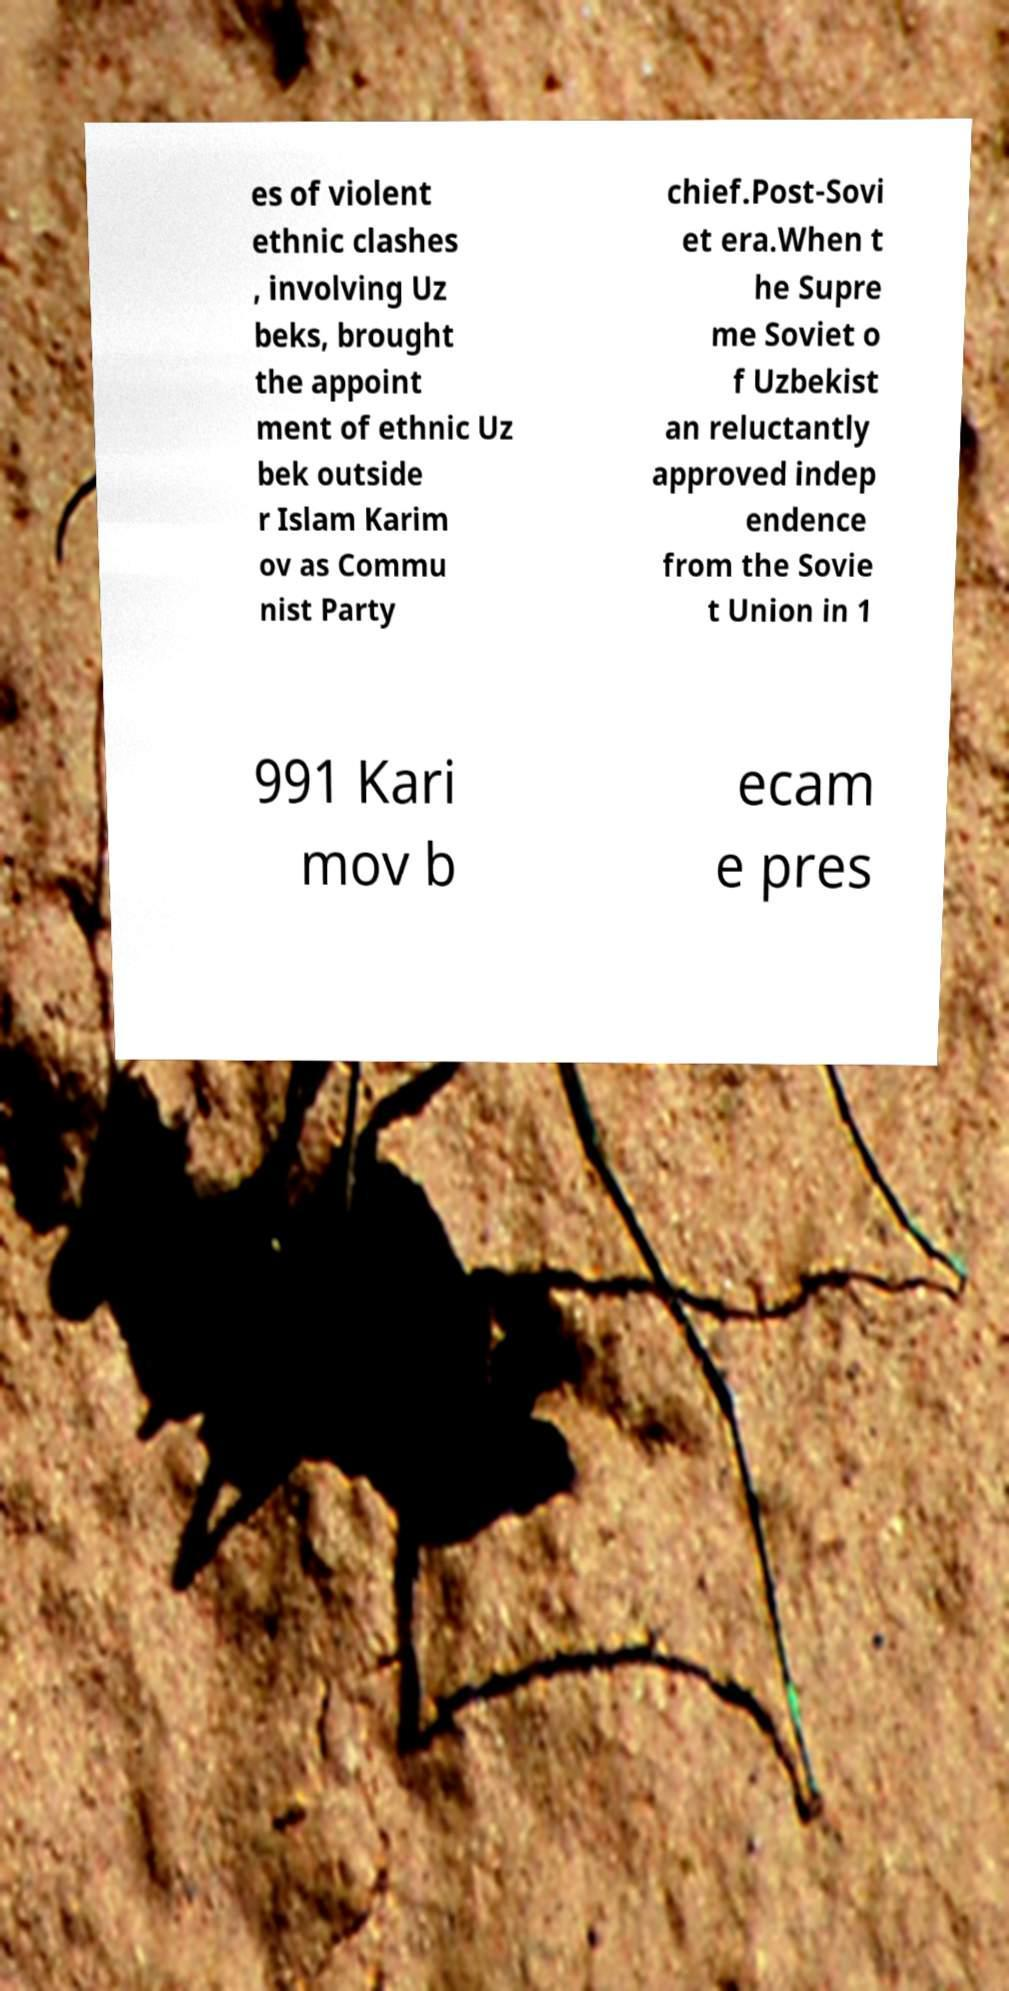Please read and relay the text visible in this image. What does it say? es of violent ethnic clashes , involving Uz beks, brought the appoint ment of ethnic Uz bek outside r Islam Karim ov as Commu nist Party chief.Post-Sovi et era.When t he Supre me Soviet o f Uzbekist an reluctantly approved indep endence from the Sovie t Union in 1 991 Kari mov b ecam e pres 